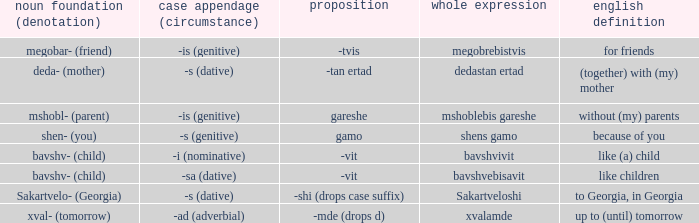What is English Meaning, when Case Suffix (Case) is "-sa (dative)"? Like children. 